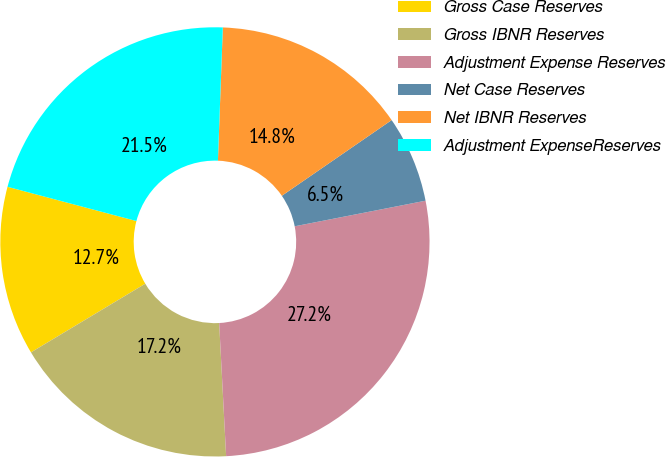Convert chart to OTSL. <chart><loc_0><loc_0><loc_500><loc_500><pie_chart><fcel>Gross Case Reserves<fcel>Gross IBNR Reserves<fcel>Adjustment Expense Reserves<fcel>Net Case Reserves<fcel>Net IBNR Reserves<fcel>Adjustment ExpenseReserves<nl><fcel>12.74%<fcel>17.22%<fcel>27.24%<fcel>6.53%<fcel>14.81%<fcel>21.45%<nl></chart> 